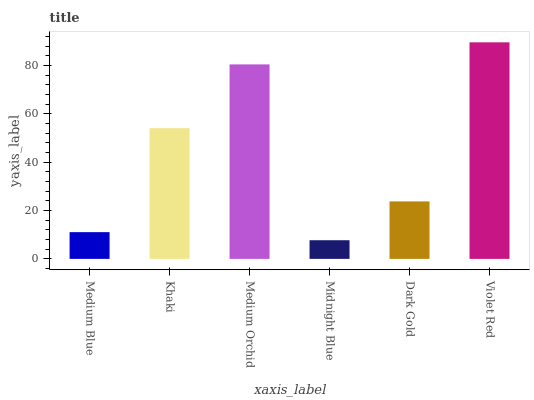Is Midnight Blue the minimum?
Answer yes or no. Yes. Is Violet Red the maximum?
Answer yes or no. Yes. Is Khaki the minimum?
Answer yes or no. No. Is Khaki the maximum?
Answer yes or no. No. Is Khaki greater than Medium Blue?
Answer yes or no. Yes. Is Medium Blue less than Khaki?
Answer yes or no. Yes. Is Medium Blue greater than Khaki?
Answer yes or no. No. Is Khaki less than Medium Blue?
Answer yes or no. No. Is Khaki the high median?
Answer yes or no. Yes. Is Dark Gold the low median?
Answer yes or no. Yes. Is Midnight Blue the high median?
Answer yes or no. No. Is Khaki the low median?
Answer yes or no. No. 